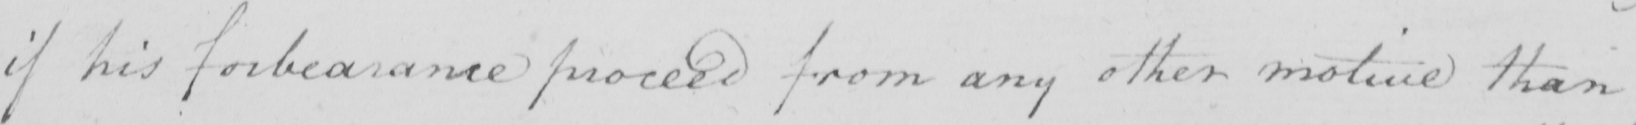Transcribe the text shown in this historical manuscript line. if his forbearance proceed from any other motive than 